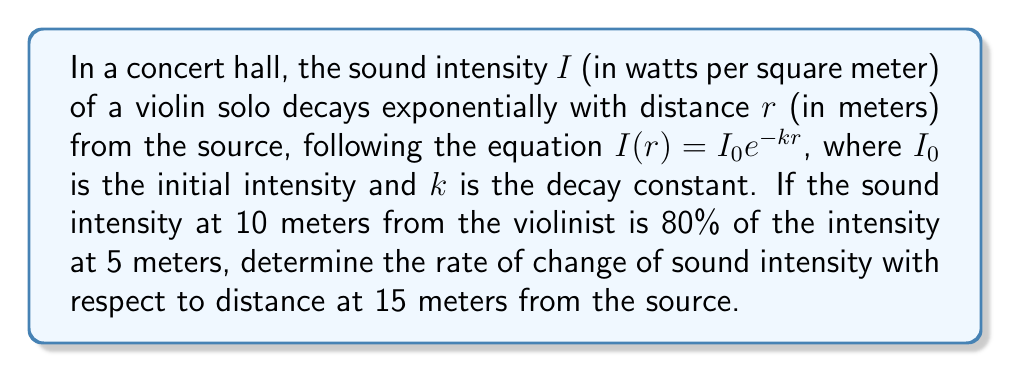Teach me how to tackle this problem. 1) First, we need to find the decay constant $k$ using the given information:
   $\frac{I(10)}{I(5)} = 0.8$

2) Substituting the equation for $I(r)$:
   $\frac{I_0e^{-k(10)}}{I_0e^{-k(5)}} = 0.8$

3) The $I_0$ terms cancel out:
   $\frac{e^{-10k}}{e^{-5k}} = 0.8$

4) Simplify:
   $e^{-5k} = 0.8$

5) Take the natural log of both sides:
   $-5k = \ln(0.8)$

6) Solve for $k$:
   $k = -\frac{\ln(0.8)}{5} \approx 0.0446$

7) Now that we have $k$, we can find the rate of change of intensity with respect to distance using the derivative:
   $\frac{dI}{dr} = -kI_0e^{-kr}$

8) At 15 meters, this becomes:
   $\frac{dI}{dr}|_{r=15} = -kI_0e^{-k(15)}$

9) We don't know $I_0$, but we can express it in terms of $I(15)$:
   $I(15) = I_0e^{-k(15)}$
   $I_0 = I(15)e^{k(15)}$

10) Substitute this into our derivative:
    $\frac{dI}{dr}|_{r=15} = -k[I(15)e^{k(15)}]e^{-k(15)} = -kI(15)$

11) Substitute the value of $k$:
    $\frac{dI}{dr}|_{r=15} = -0.0446I(15)$

This means the rate of change of sound intensity at 15 meters is -0.0446 times the intensity at that point.
Answer: $-0.0446I(15)$ watts per square meter per meter 